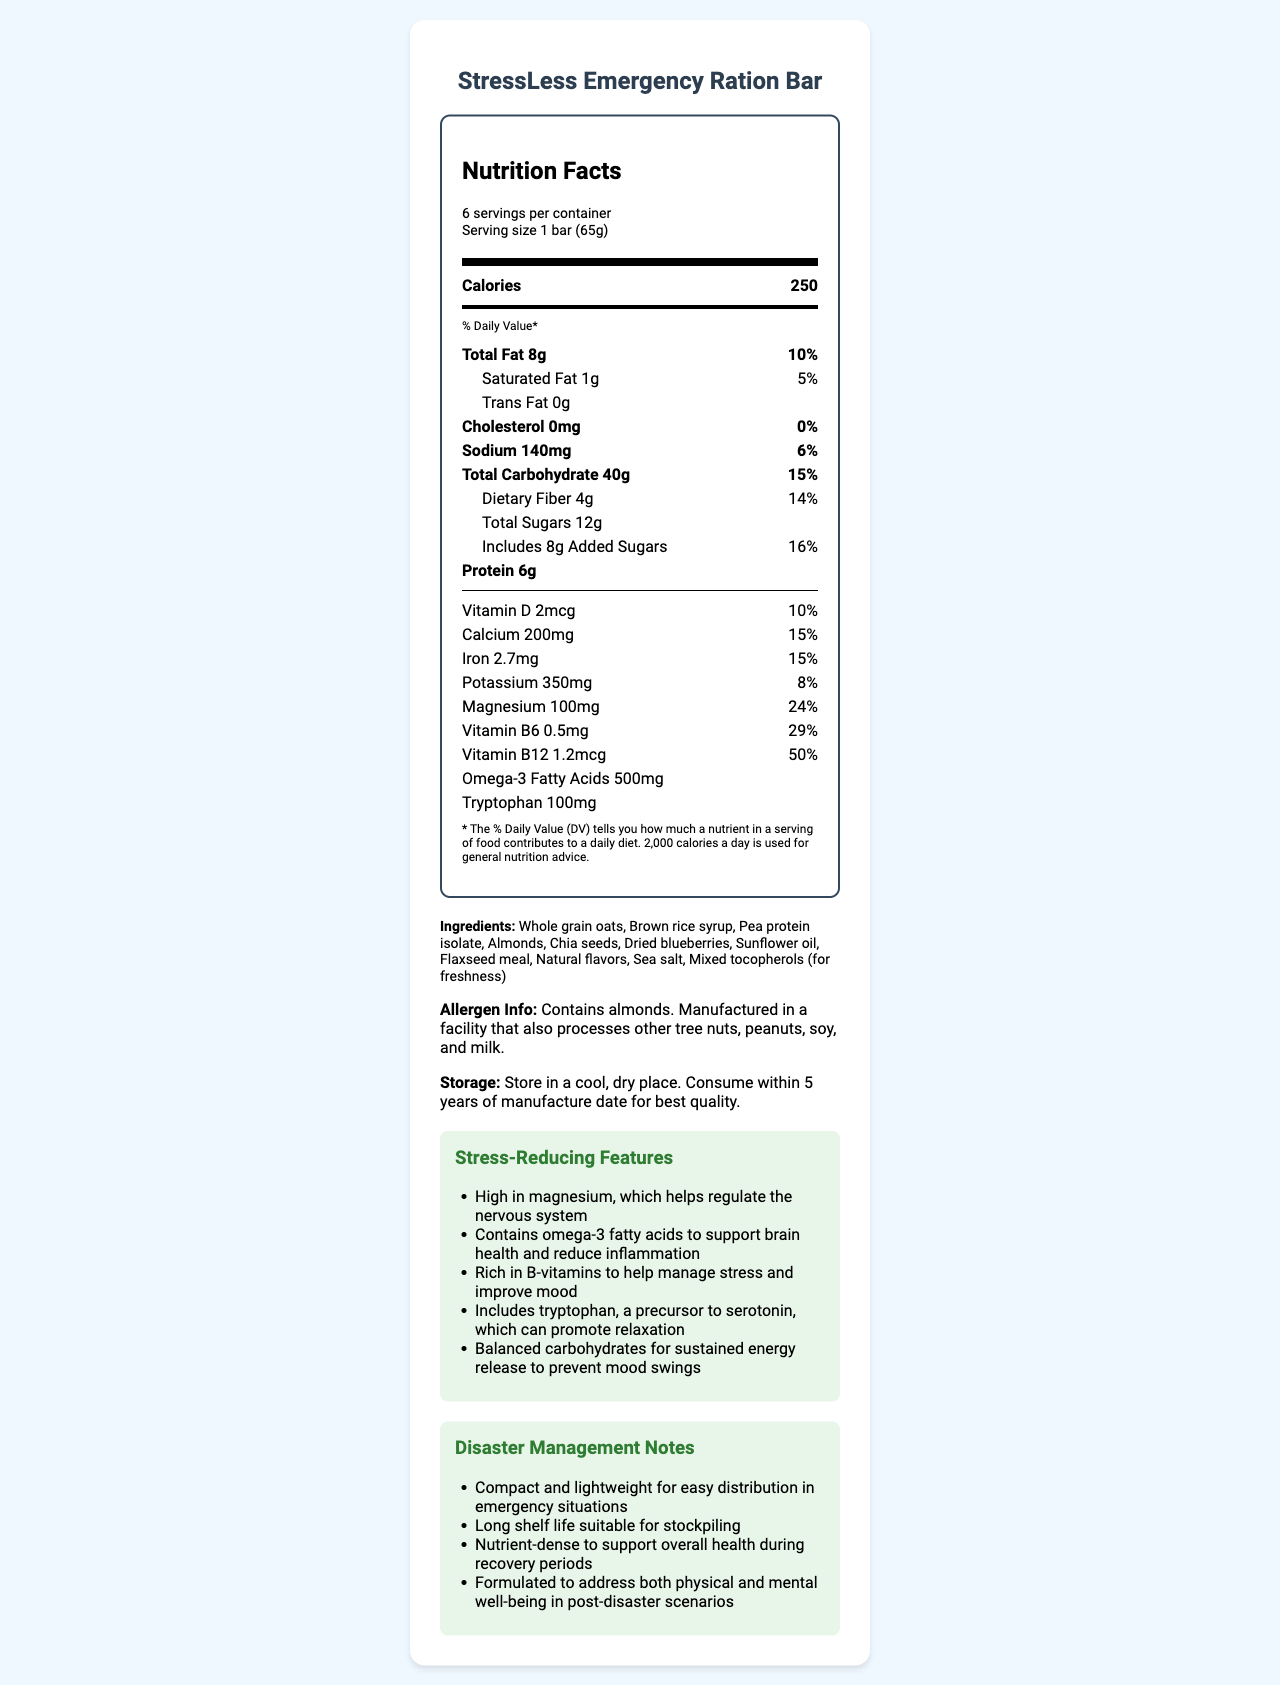what is the serving size for the StressLess Emergency Ration Bar? The serving size is directly mentioned in the "serving size" section of the Nutrition Facts Label.
Answer: 1 bar (65g) how many calories are there per serving? The number of calories per serving is listed right below the serving size and servings per container information in the "Calories" section.
Answer: 250 what percentage of the daily value of Magnesium is in one serving? The percentage daily value for Magnesium is listed in the section under "Magnesium" with the value shown as 24%.
Answer: 24% which ingredients in the StressLess Emergency Ration Bar are potential allergens? The allergen information states that the product contains almonds.
Answer: Almonds how much protein is in one bar? The amount of protein per serving is listed under the "Protein" section with the value shown as 6g.
Answer: 6g which nutrient is included in the highest daily value percentage? A. Vitamin D B. Vitamin B6 C. Vitamin B12 D. Magnesium Vitamin B12 has the highest daily value percentage at 50%, which is evident when comparing the daily value percentages of the listed nutrients.
Answer: C. Vitamin B12 how much Omega-3 Fatty Acids does the bar contain? The amount of Omega-3 Fatty Acids is listed under its own section with the value shown as 500mg.
Answer: 500mg does the bar contain any trans fat? The label shows "0g" next to Trans Fat, indicating that the bar does not contain any trans fat.
Answer: No what are the key stress-reducing features of the bar? These features are listed under the "Stress-Reducing Features" section of the document.
Answer: High in magnesium, contains omega-3 fatty acids, rich in B-vitamins, includes tryptophan, balanced carbohydrates describe the purpose of including tryptophan in the bar The role of tryptophan in promoting relaxation is explained in the "Stress-Reducing Features" section where it mentions that tryptophan can promote relaxation by being a precursor to serotonin.
Answer: To promote relaxation as it is a precursor to serotonin what is the shelf life of the bar? The storage instructions mention consuming the bar within 5 years of the manufacture date for the best quality.
Answer: 5 years how much dietary fiber does each bar contain? The amount of dietary fiber per serving is listed under the "Dietary Fiber" section with the value shown as 4g.
Answer: 4g which nutrient helps to regulate the nervous system? The stress-reducing features section states that magnesium helps regulate the nervous system.
Answer: Magnesium which vitamin has a daily value percentage of 29%? A. Vitamin D B. Vitamin B6 C. Vitamin B12 D. Iron Vitamin B6 has a daily value percentage of 29%, as listed directly under its section.
Answer: B. Vitamin B6 which storage condition is recommended for the bar? A. Refrigerate B. Store in a cool, dry place C. Keep in direct sunlight The storage instructions section advises storing the bar in a cool, dry place.
Answer: B. Store in a cool, dry place what is the main purpose of this document? The document provides comprehensive information on the nutritional content of the bar, its stress-reducing features, and its suitability for disaster management scenarios.
Answer: To provide detailed nutritional information about the StressLess Emergency Ration Bar, highlighting its relevance for disaster management and mental health support. what is the manufacturing facility cross-contaminated with? The document states the bar is manufactured in a facility that processes other tree nuts, peanuts, soy, and milk, but does not specify actual cross-contamination.
Answer: Cannot be determined how many servings are there per container? The serving information states that there are 6 servings per container.
Answer: 6 what are the disaster management characteristics of the bar? These characteristics are listed under the "Disaster Management Notes" section, providing an overview of how the bar is designed to be suitable for emergency situations.
Answer: Compact and lightweight, long shelf life, nutrient-dense, supports both physical and mental well-being 